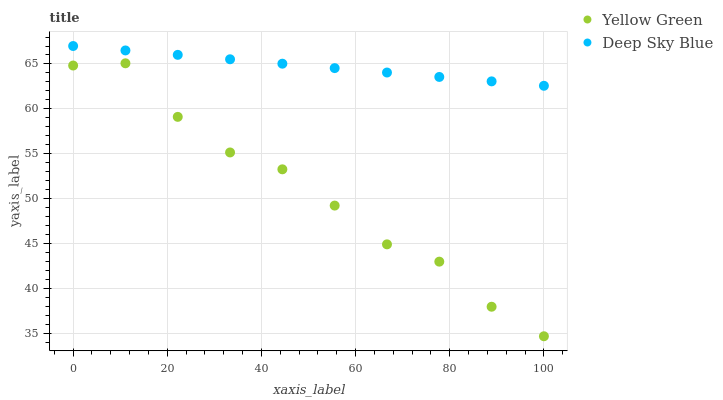Does Yellow Green have the minimum area under the curve?
Answer yes or no. Yes. Does Deep Sky Blue have the maximum area under the curve?
Answer yes or no. Yes. Does Deep Sky Blue have the minimum area under the curve?
Answer yes or no. No. Is Deep Sky Blue the smoothest?
Answer yes or no. Yes. Is Yellow Green the roughest?
Answer yes or no. Yes. Is Deep Sky Blue the roughest?
Answer yes or no. No. Does Yellow Green have the lowest value?
Answer yes or no. Yes. Does Deep Sky Blue have the lowest value?
Answer yes or no. No. Does Deep Sky Blue have the highest value?
Answer yes or no. Yes. Is Yellow Green less than Deep Sky Blue?
Answer yes or no. Yes. Is Deep Sky Blue greater than Yellow Green?
Answer yes or no. Yes. Does Yellow Green intersect Deep Sky Blue?
Answer yes or no. No. 